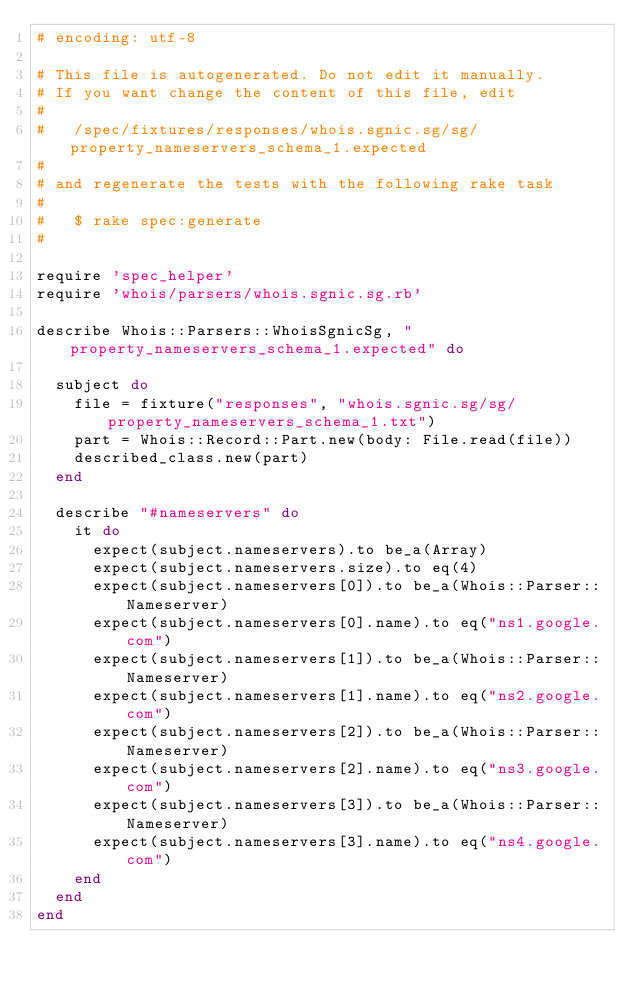<code> <loc_0><loc_0><loc_500><loc_500><_Ruby_># encoding: utf-8

# This file is autogenerated. Do not edit it manually.
# If you want change the content of this file, edit
#
#   /spec/fixtures/responses/whois.sgnic.sg/sg/property_nameservers_schema_1.expected
#
# and regenerate the tests with the following rake task
#
#   $ rake spec:generate
#

require 'spec_helper'
require 'whois/parsers/whois.sgnic.sg.rb'

describe Whois::Parsers::WhoisSgnicSg, "property_nameservers_schema_1.expected" do

  subject do
    file = fixture("responses", "whois.sgnic.sg/sg/property_nameservers_schema_1.txt")
    part = Whois::Record::Part.new(body: File.read(file))
    described_class.new(part)
  end

  describe "#nameservers" do
    it do
      expect(subject.nameservers).to be_a(Array)
      expect(subject.nameservers.size).to eq(4)
      expect(subject.nameservers[0]).to be_a(Whois::Parser::Nameserver)
      expect(subject.nameservers[0].name).to eq("ns1.google.com")
      expect(subject.nameservers[1]).to be_a(Whois::Parser::Nameserver)
      expect(subject.nameservers[1].name).to eq("ns2.google.com")
      expect(subject.nameservers[2]).to be_a(Whois::Parser::Nameserver)
      expect(subject.nameservers[2].name).to eq("ns3.google.com")
      expect(subject.nameservers[3]).to be_a(Whois::Parser::Nameserver)
      expect(subject.nameservers[3].name).to eq("ns4.google.com")
    end
  end
end
</code> 